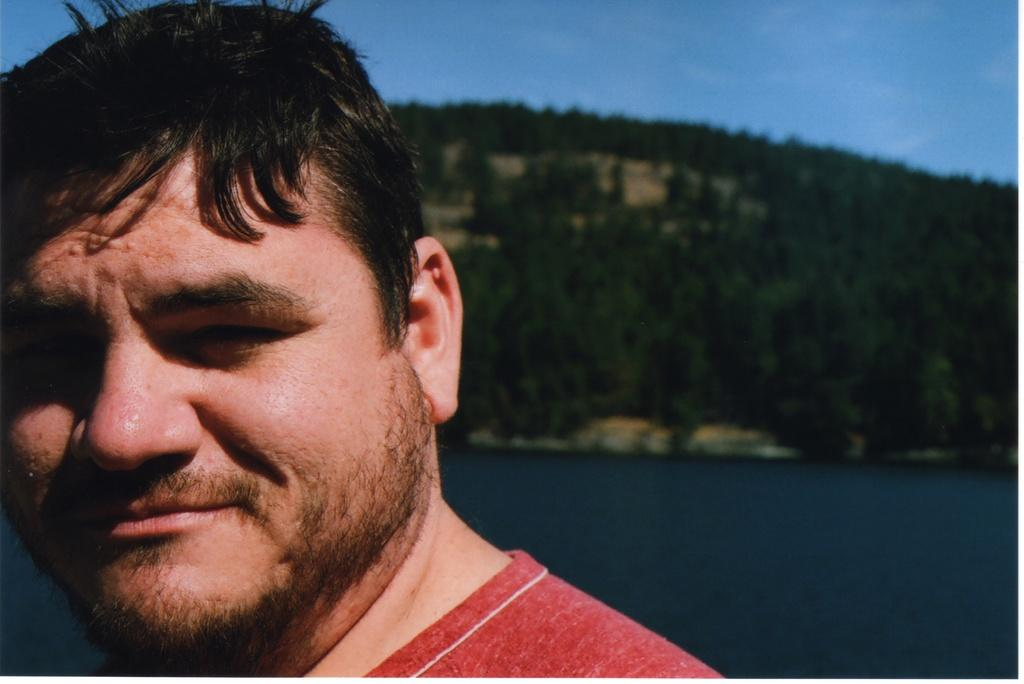What is the main subject of the image? There is a person in the image. How is the person's expression in the image? The person is smiling. What can be seen in the image besides the person? There is water in the image. What is visible in the background of the image? There are trees in the background of the image. What is the price of the wire in the image? There is no wire present in the image, so it is not possible to determine its price. 